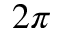<formula> <loc_0><loc_0><loc_500><loc_500>2 \pi</formula> 